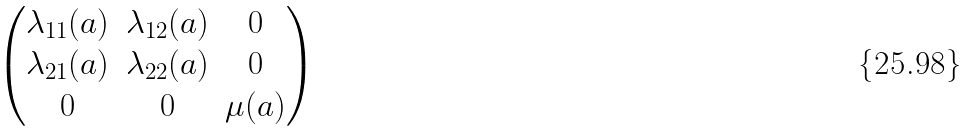<formula> <loc_0><loc_0><loc_500><loc_500>\begin{pmatrix} \lambda _ { 1 1 } ( a ) & \lambda _ { 1 2 } ( a ) & 0 \\ \lambda _ { 2 1 } ( a ) & \lambda _ { 2 2 } ( a ) & 0 \\ 0 & 0 & \mu ( a ) \end{pmatrix}</formula> 